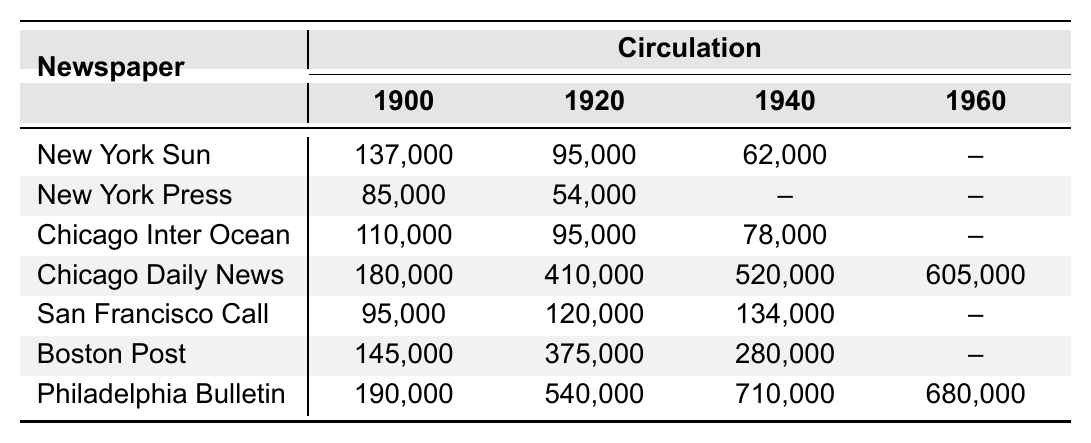What was the circulation of the Chicago Daily News in 1960? The table shows that the circulation of the Chicago Daily News in 1960 was 605,000.
Answer: 605,000 Which newspaper had the highest circulation in 1940? In 1940, the Philadelphia Bulletin had the highest circulation with 710,000, as indicated in the table.
Answer: Philadelphia Bulletin What is the difference in circulation between the New York Sun in 1900 and the San Francisco Call in 1920? The New York Sun had a circulation of 137,000 in 1900 and the San Francisco Call had 120,000 in 1920. The difference is 137,000 - 120,000 = 17,000.
Answer: 17,000 Did the circulation of the Boston Post increase or decrease from 1920 to 1940? The circulation of the Boston Post was 375,000 in 1920 and decreased to 280,000 in 1940, indicating a decrease.
Answer: Decrease What was the average circulation of the Philadelphia Bulletin from 1900 to 1960? To find the average, sum the circulations for the Philadelphia Bulletin: 190,000 (1900) + 540,000 (1920) + 710,000 (1940) + 680,000 (1960) = 2,120,000. There are four data points, so the average is 2,120,000 / 4 = 530,000.
Answer: 530,000 Which city had the defunct newspaper with the second highest circulation in 1920? The Chicago Daily News had the second highest circulation in 1920, at 410,000. The Chicago Inter Ocean had 95,000, and the Philadelphia Bulletin had 540,000 but is not second.
Answer: Chicago Daily News How many newspapers had a circulation of over 100,000 in 1940? In 1940, three newspapers had circulations over 100,000: the Chicago Daily News (520,000), the Philadelphia Bulletin (710,000), and the Boston Post (280,000).
Answer: 3 What was the total circulation for the New York Press from 1900 to 1940? The New York Press had a circulation of 85,000 (1900) + 54,000 (1920) = 139,000. There were no figures for 1940, so the total circulation is 139,000.
Answer: 139,000 Is it true that all newspapers listed had their circulation documented for 1960? No, it is false. The New York Sun, New York Press, and San Francisco Call do not have documented circulation for 1960, as indicated by the "--" symbol in the table.
Answer: No Which newspaper saw the largest increase in circulation from 1920 to 1960? The Chicago Daily News saw the largest increase: 410,000 (1920) to 605,000 (1960) which is an increase of 195,000.
Answer: Chicago Daily News 